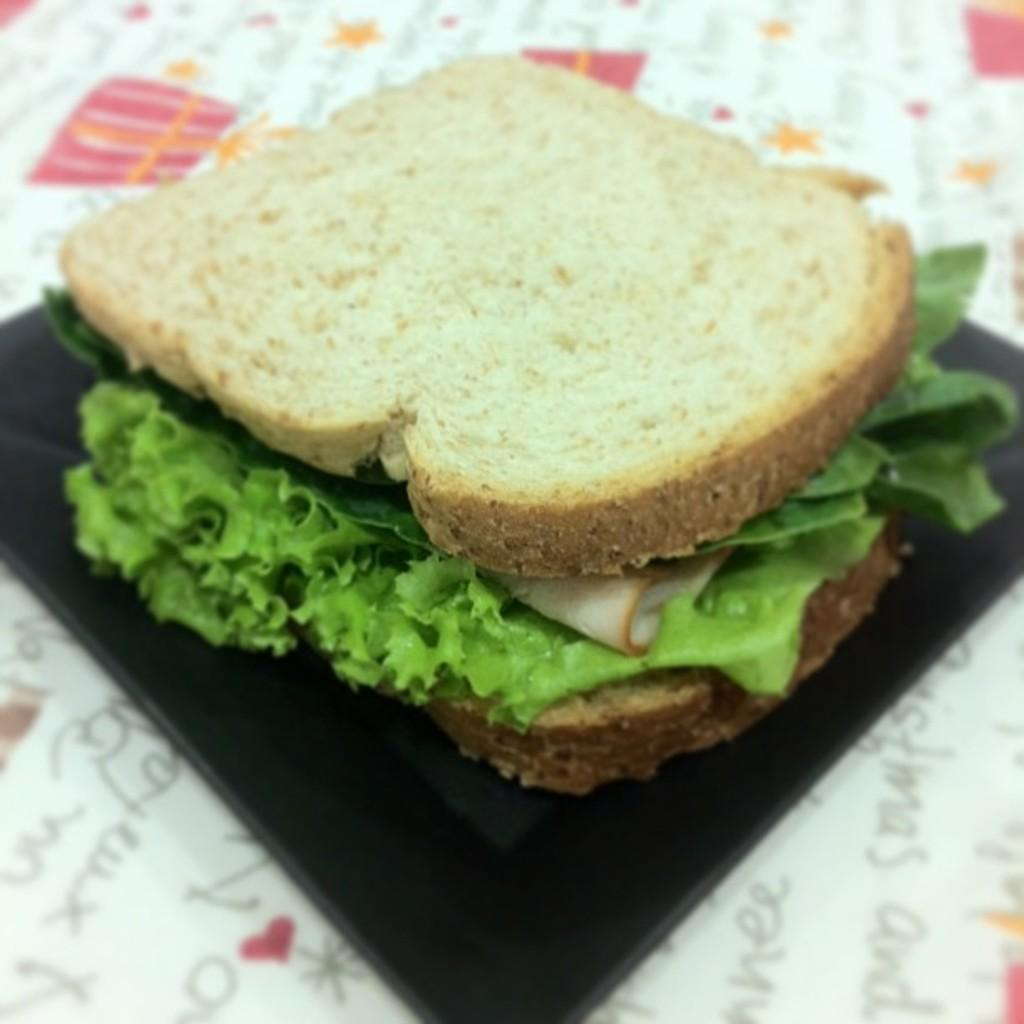What type of items can be seen in the image? There are food products in the image. What color is the plate that holds the food products? There is a black color plate in the image. What type of road can be seen in the image? There is no road present in the image; it features food products on a black color plate. How many waves are visible in the image? There are no waves present in the image; it features food products on a black color plate. 